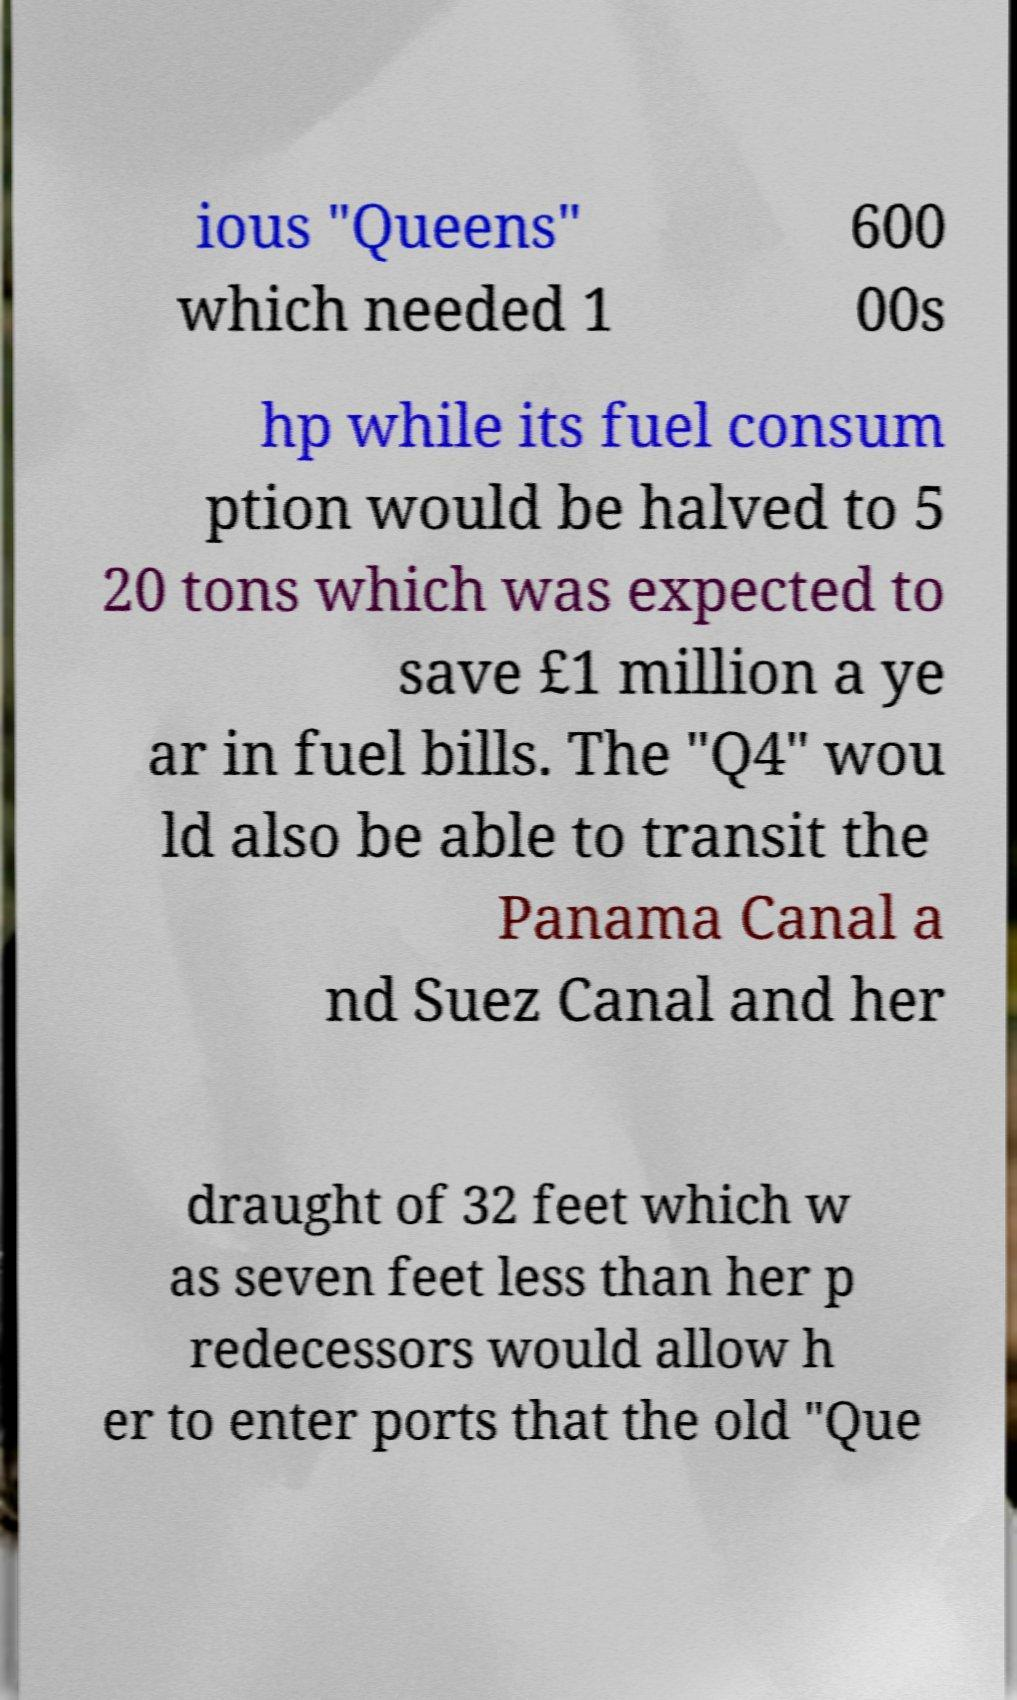Could you extract and type out the text from this image? ious "Queens" which needed 1 600 00s hp while its fuel consum ption would be halved to 5 20 tons which was expected to save £1 million a ye ar in fuel bills. The "Q4" wou ld also be able to transit the Panama Canal a nd Suez Canal and her draught of 32 feet which w as seven feet less than her p redecessors would allow h er to enter ports that the old "Que 